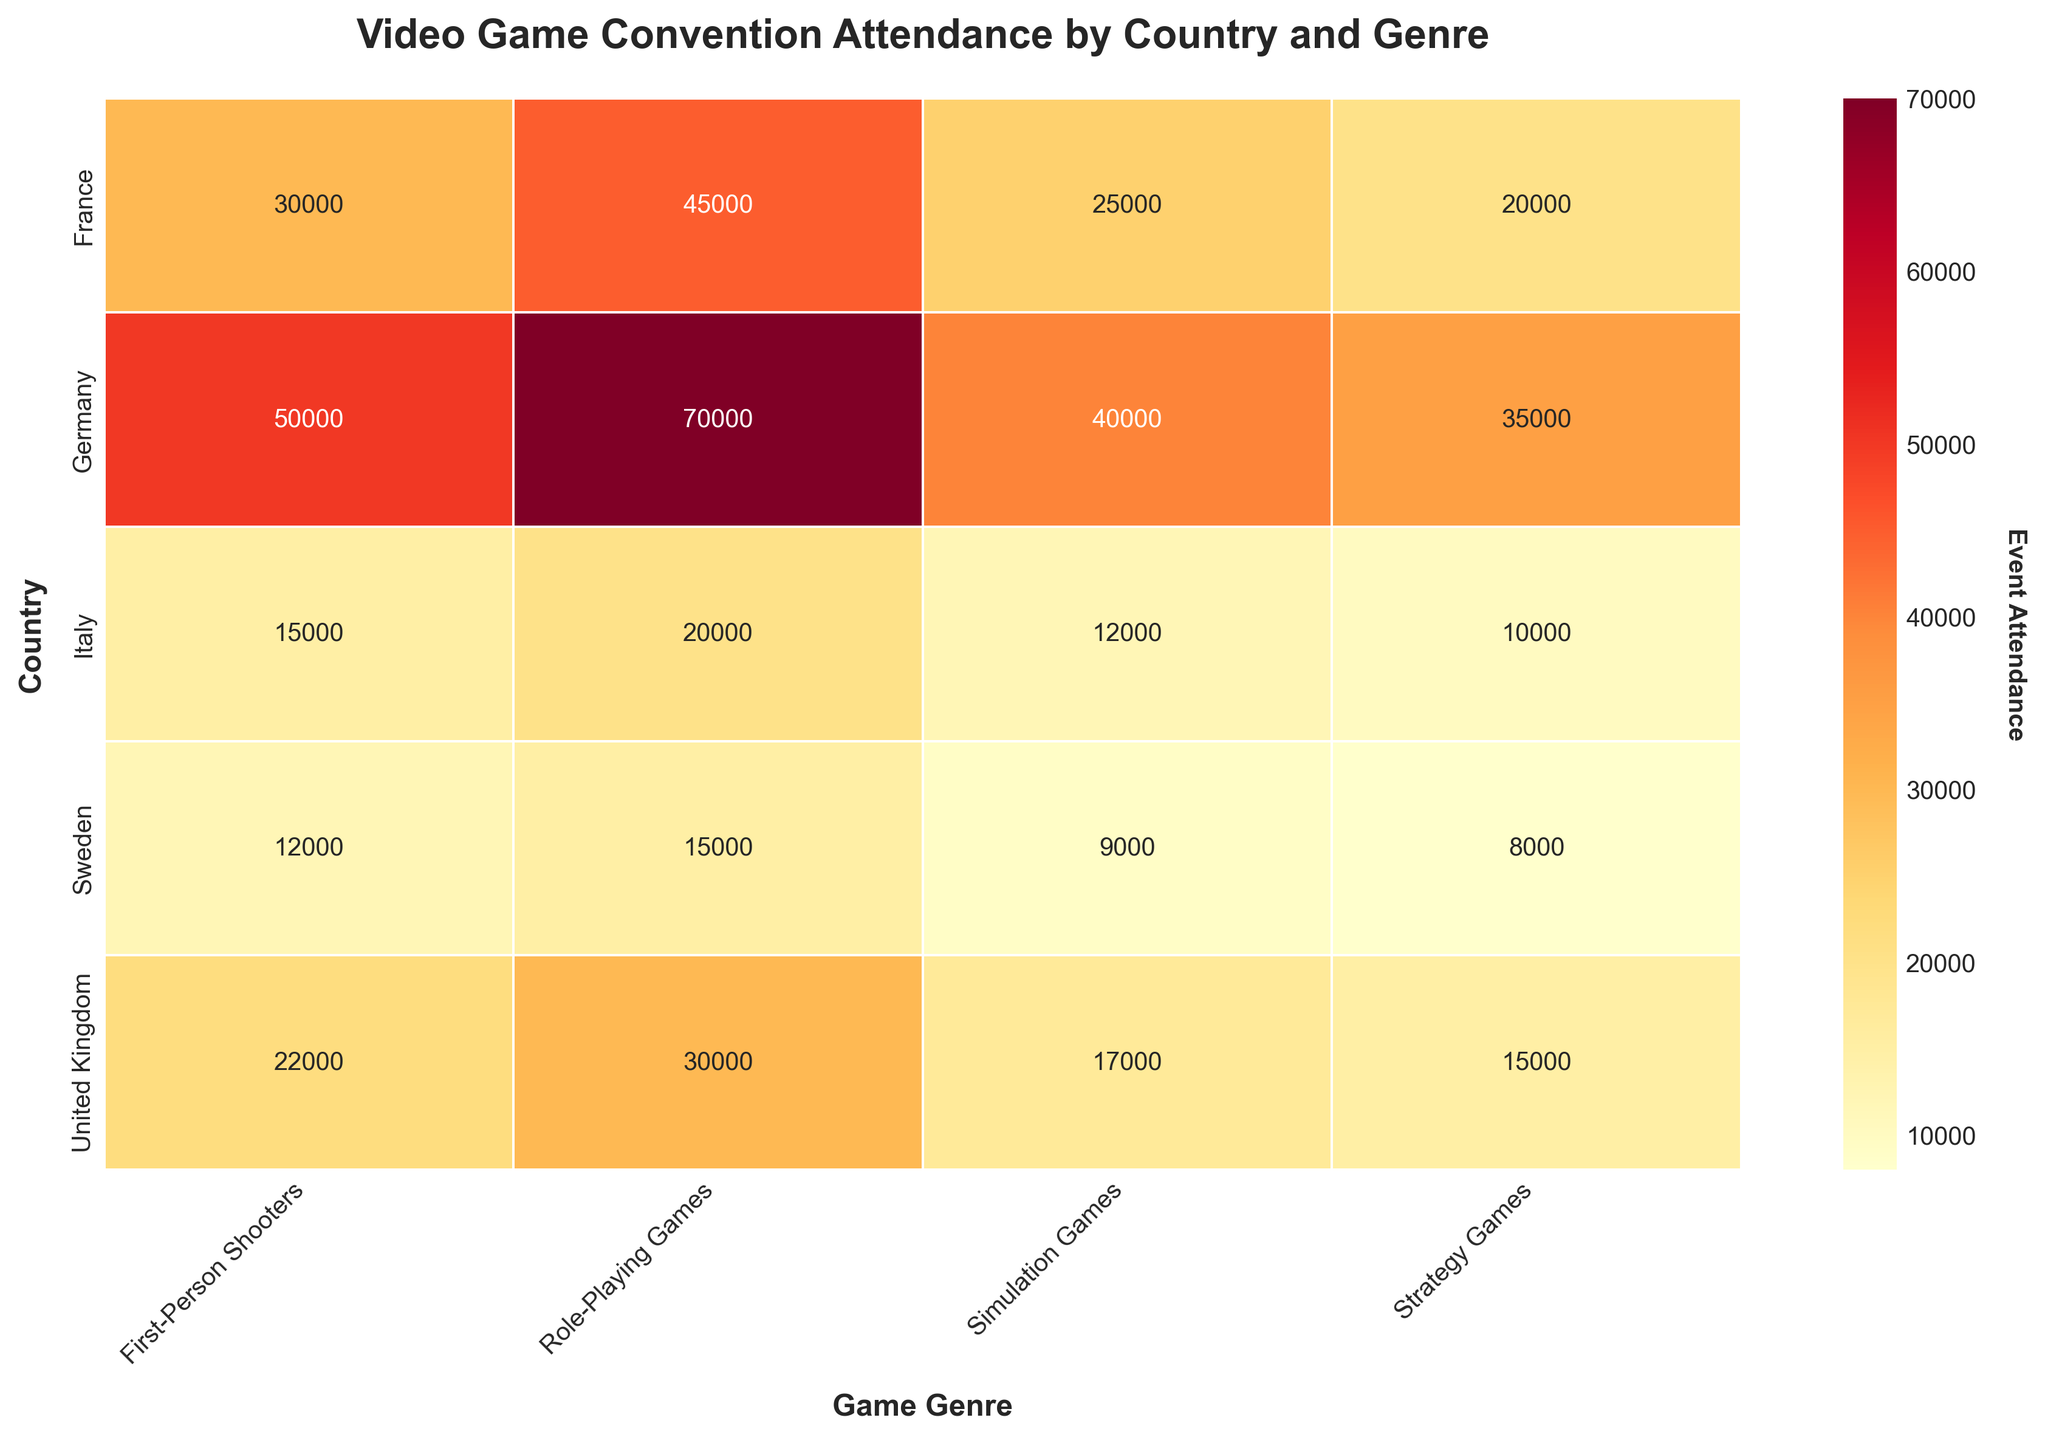What is the title of the heatmap? The title can be found at the top of the heatmap plot. It provides a summary of what the visualization is about.
Answer: Video Game Convention Attendance by Country and Genre Which country has the highest attendance for Role-Playing Games? Look at the values in the Role-Playing Games column for each country and identify the highest number.
Answer: Germany How much higher is the attendance for Role-Playing Games in Germany compared to France? Find the attendance numbers for Role-Playing Games in Germany and France. Subtract the French attendance from the German attendance to find the difference.
Answer: 70000-45000 = 25000 Which country shows the lowest attendance for Simulation Games? Look at the values in the Simulation Games column for each country and identify the smallest number.
Answer: Sweden Compare the total attendance for all game genres in the United Kingdom and France. Which country has the higher total attendance? Sum the attendance numbers for each genre in the United Kingdom and France, then compare the totals.
Answer: France What is the average attendance for Strategy Games across all countries? Sum the attendance numbers for Strategy Games in each country and divide by the number of countries (5).
Answer: (8000+35000+20000+15000+10000)/5 = 17600 Which genre has the highest attendance in Sweden and what is the attendance figure? Find the country and check the attendance values for each genre. Identify the genre with the highest value.
Answer: Role-Playing Games, 15000 For Italy, what is the difference between the highest and lowest attendance figures among all genres? Identify the highest and lowest attendance values for Italy, then subtract the lowest from the highest.
Answer: 20000-10000 = 10000 What is the median attendance for First-Person Shooters across all countries? Arrange the attendance numbers for First-Person Shooters in ascending order and find the middle value.
Answer: 22000 Which game genre in Germany has the lowest attendance, and what is the figure? Look at the values for each genre in Germany and identify the smallest number.
Answer: Strategy Games, 35000 